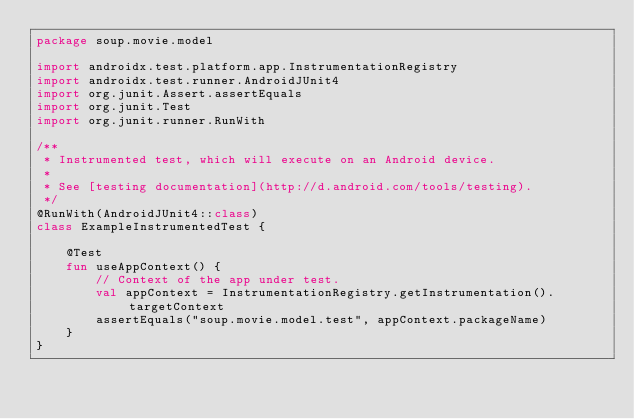Convert code to text. <code><loc_0><loc_0><loc_500><loc_500><_Kotlin_>package soup.movie.model

import androidx.test.platform.app.InstrumentationRegistry
import androidx.test.runner.AndroidJUnit4
import org.junit.Assert.assertEquals
import org.junit.Test
import org.junit.runner.RunWith

/**
 * Instrumented test, which will execute on an Android device.
 *
 * See [testing documentation](http://d.android.com/tools/testing).
 */
@RunWith(AndroidJUnit4::class)
class ExampleInstrumentedTest {

    @Test
    fun useAppContext() {
        // Context of the app under test.
        val appContext = InstrumentationRegistry.getInstrumentation().targetContext
        assertEquals("soup.movie.model.test", appContext.packageName)
    }
}
</code> 